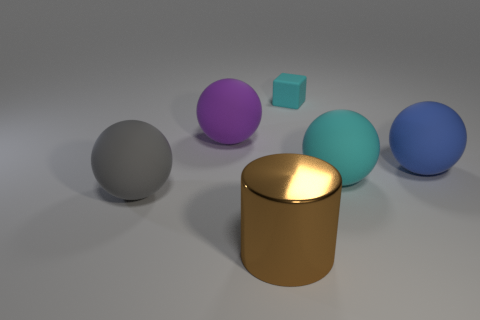Subtract all big gray rubber balls. How many balls are left? 3 Add 1 large gray rubber spheres. How many objects exist? 7 Subtract all purple balls. How many balls are left? 3 Subtract all cyan spheres. Subtract all yellow cubes. How many spheres are left? 3 Subtract all cylinders. How many objects are left? 5 Subtract 0 purple cubes. How many objects are left? 6 Subtract all large matte spheres. Subtract all purple spheres. How many objects are left? 1 Add 6 big matte balls. How many big matte balls are left? 10 Add 2 cyan metal blocks. How many cyan metal blocks exist? 2 